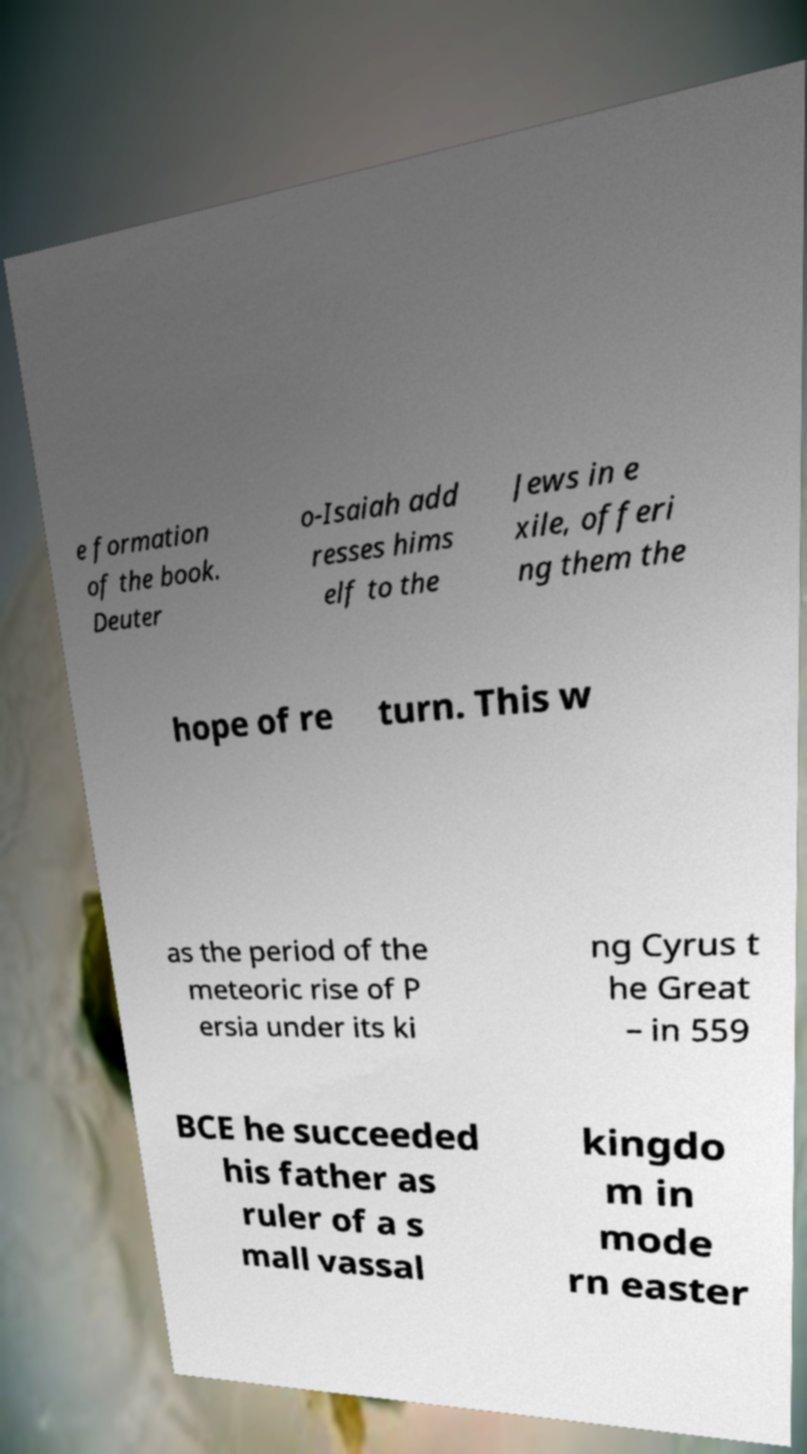Could you assist in decoding the text presented in this image and type it out clearly? e formation of the book. Deuter o-Isaiah add resses hims elf to the Jews in e xile, offeri ng them the hope of re turn. This w as the period of the meteoric rise of P ersia under its ki ng Cyrus t he Great – in 559 BCE he succeeded his father as ruler of a s mall vassal kingdo m in mode rn easter 